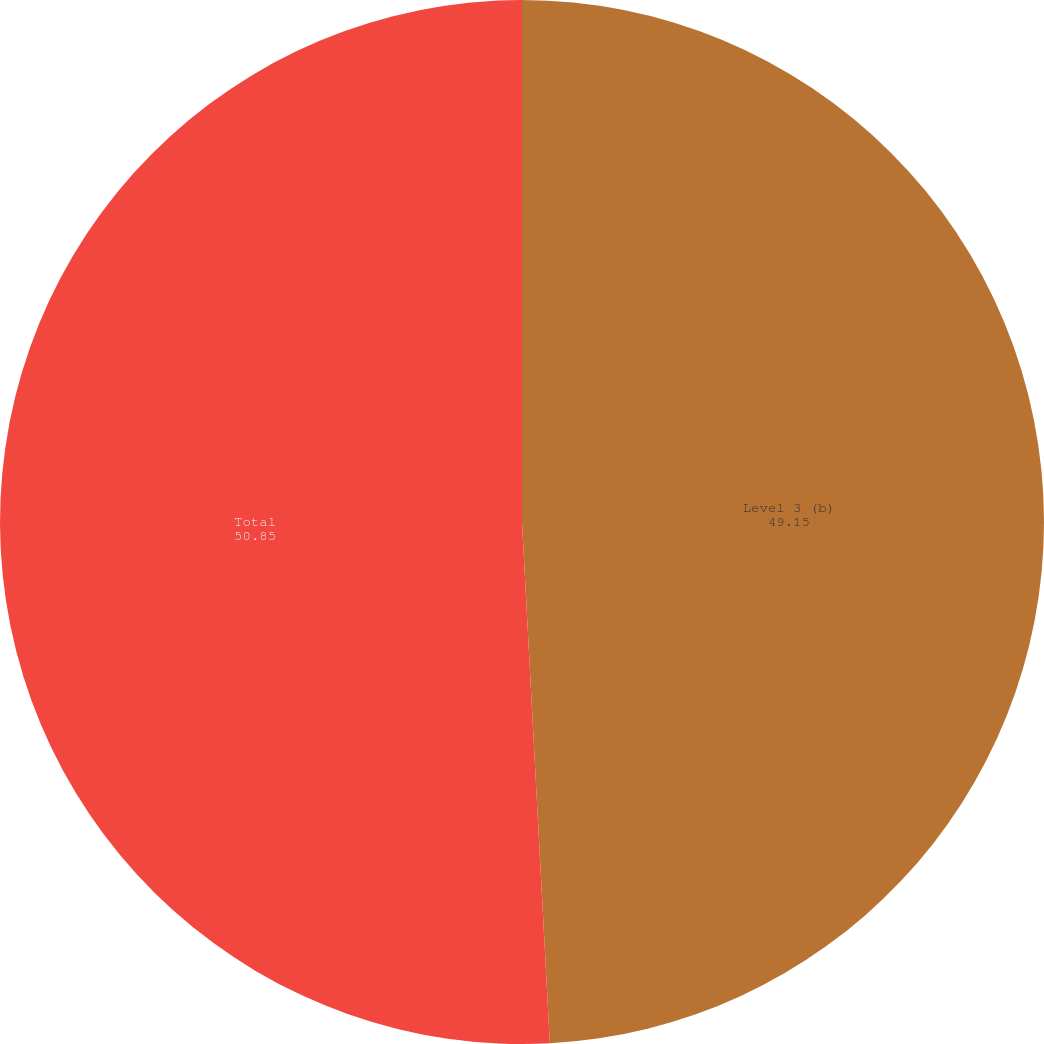Convert chart. <chart><loc_0><loc_0><loc_500><loc_500><pie_chart><fcel>Level 3 (b)<fcel>Total<nl><fcel>49.15%<fcel>50.85%<nl></chart> 